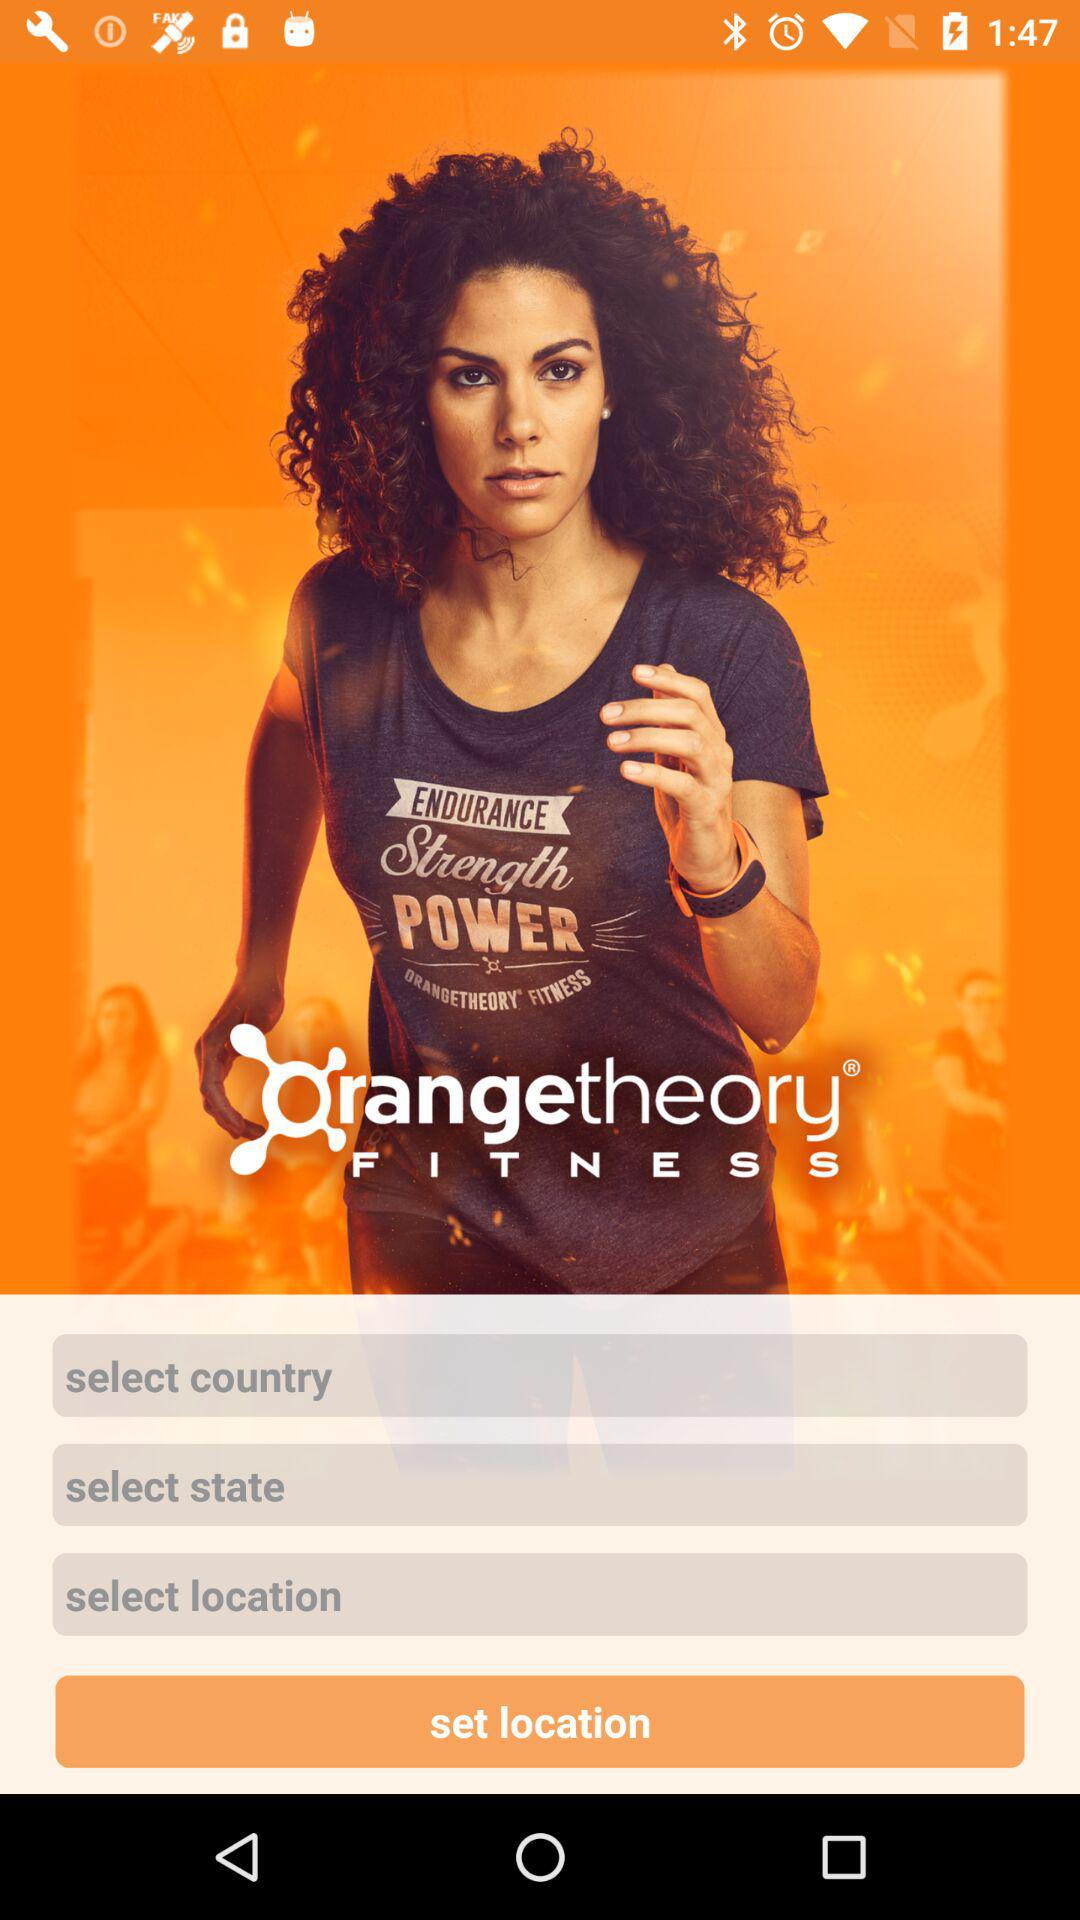Which country is set for the location?
When the provided information is insufficient, respond with <no answer>. <no answer> 